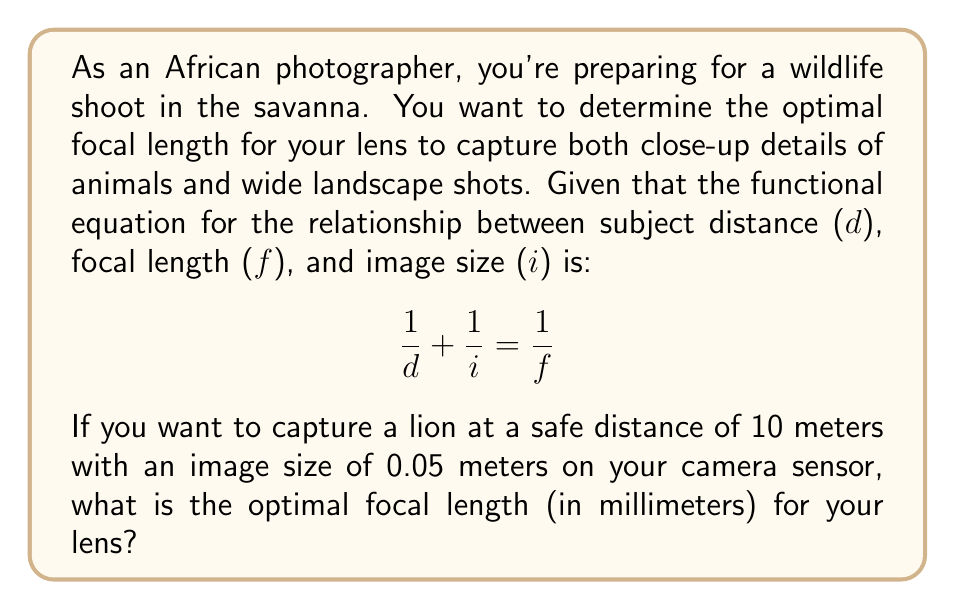Teach me how to tackle this problem. To solve this problem, we'll use the given functional equation and the information provided:

1. The functional equation: $$\frac{1}{d} + \frac{1}{i} = \frac{1}{f}$$

2. Given values:
   - Subject distance, $d = 10$ meters
   - Image size, $i = 0.05$ meters

3. Substitute these values into the equation:
   $$\frac{1}{10} + \frac{1}{0.05} = \frac{1}{f}$$

4. Simplify the left side of the equation:
   $$0.1 + 20 = \frac{1}{f}$$
   $$20.1 = \frac{1}{f}$$

5. To solve for $f$, take the reciprocal of both sides:
   $$f = \frac{1}{20.1}$$

6. Calculate the value of $f$:
   $$f \approx 0.0497$$ meters

7. Convert the focal length to millimeters:
   $$f \approx 0.0497 \times 1000 = 49.7$$ mm

Therefore, the optimal focal length for your lens is approximately 49.7 mm.
Answer: 49.7 mm 